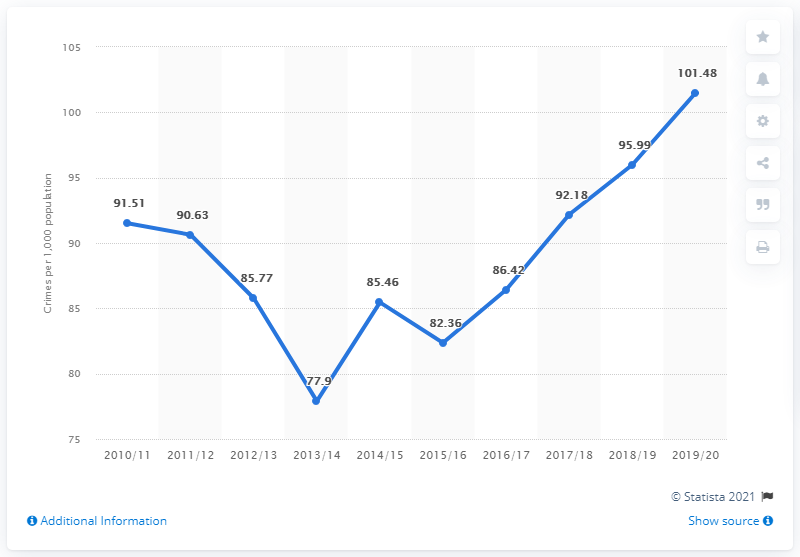Draw attention to some important aspects in this diagram. London's crime rate in 2019/20 was 101.48 reported incidents per 1,000 residents. The crime rate in London varied significantly between the years in which the maximum and minimum crime occurred, with a difference of 23.58 between the two extremes. The crime rate in London was at its highest in the years 2019/2020. 